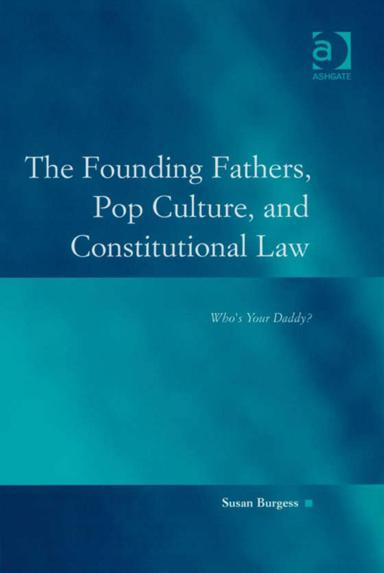Can you tell me more about the author mentioned on the book cover? Susan Burgess is a distinguished professor who extensively explores topics related to political science and public administration. Her work often delves into how cultural elements influence legal and governmental structures. 